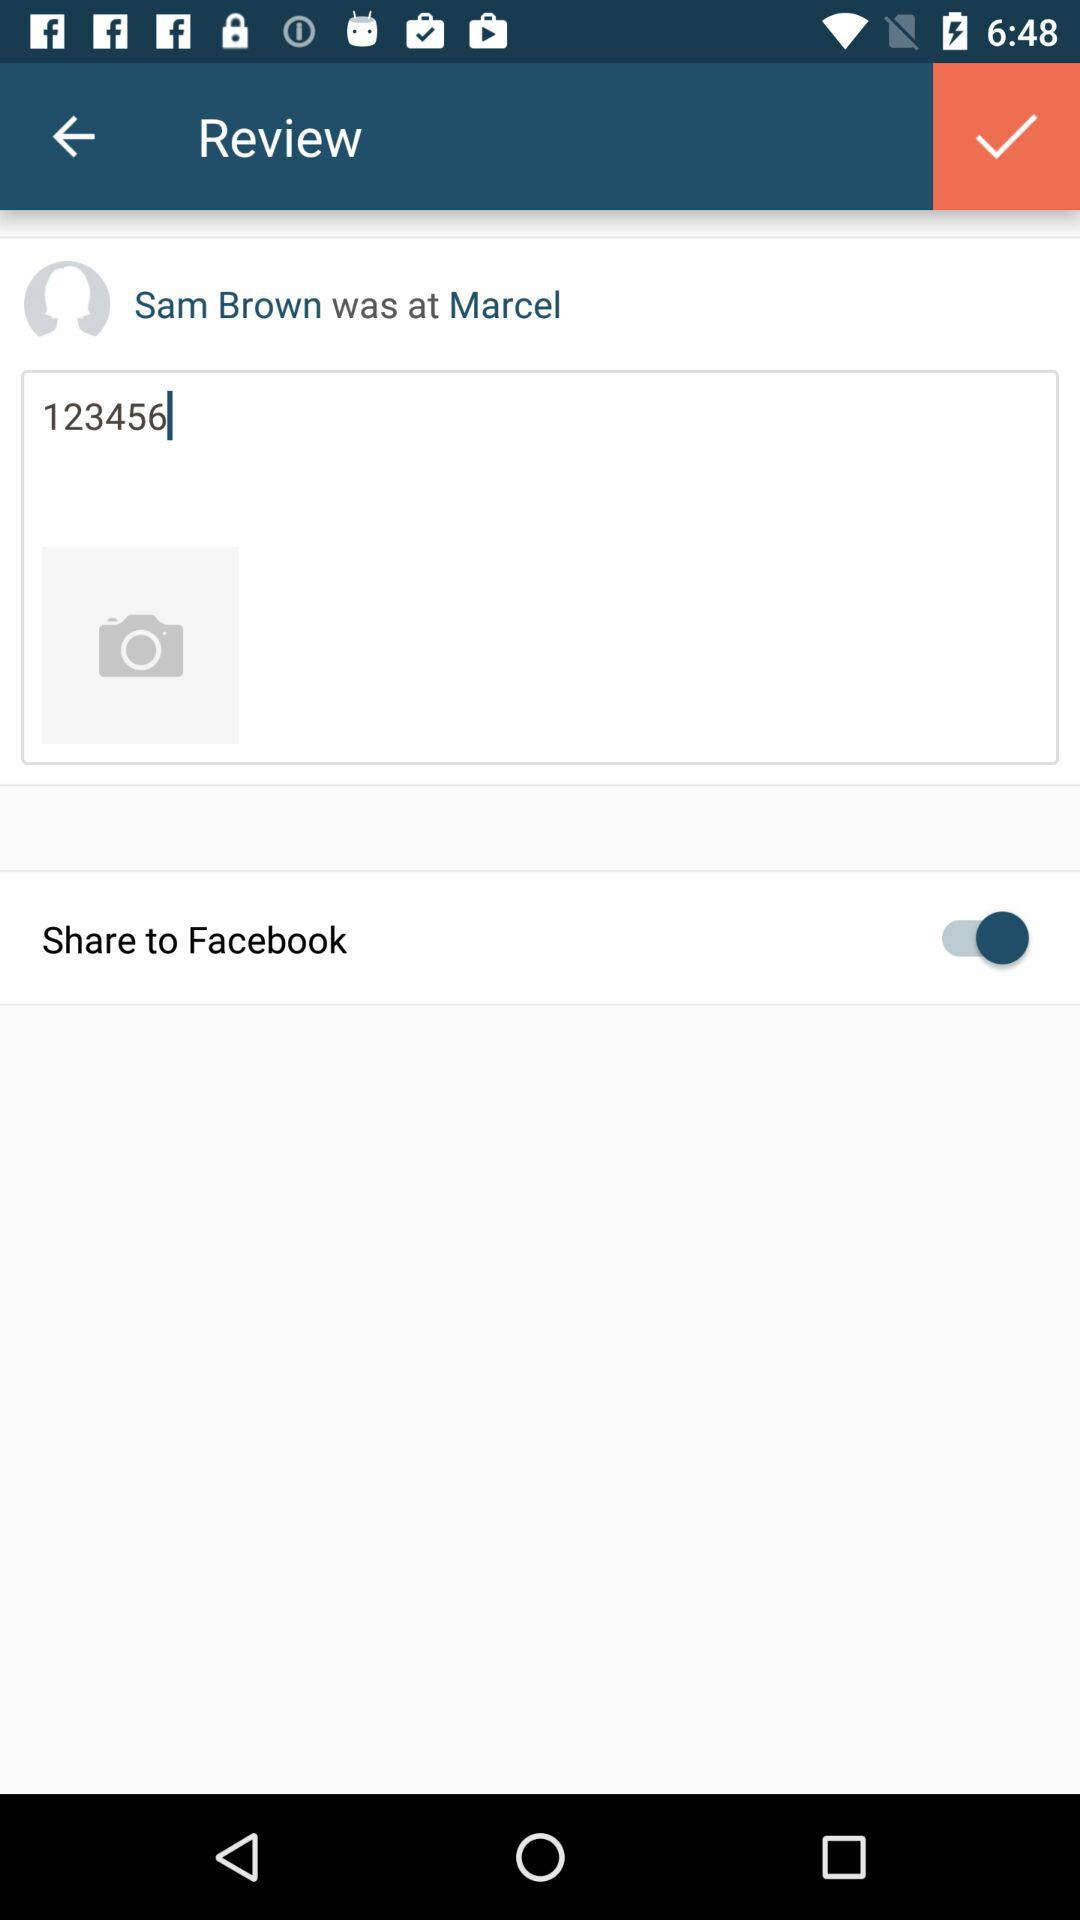What is the text entered in the input field? The entered text is "123456". 